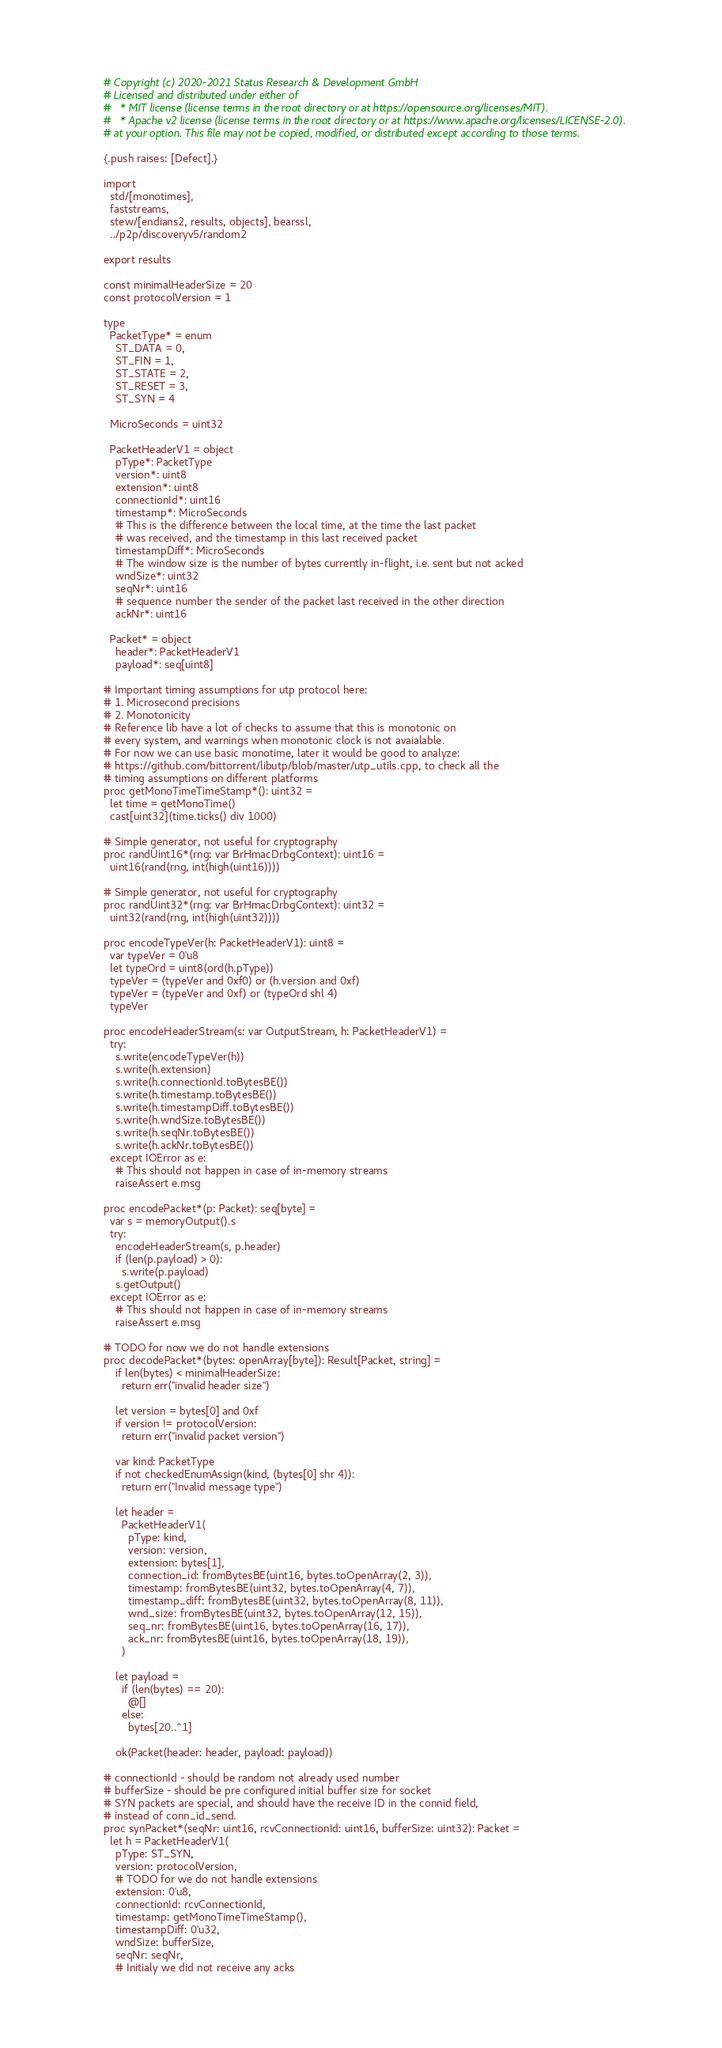Convert code to text. <code><loc_0><loc_0><loc_500><loc_500><_Nim_># Copyright (c) 2020-2021 Status Research & Development GmbH
# Licensed and distributed under either of
#   * MIT license (license terms in the root directory or at https://opensource.org/licenses/MIT).
#   * Apache v2 license (license terms in the root directory or at https://www.apache.org/licenses/LICENSE-2.0).
# at your option. This file may not be copied, modified, or distributed except according to those terms.

{.push raises: [Defect].}

import
  std/[monotimes],
  faststreams,
  stew/[endians2, results, objects], bearssl,
  ../p2p/discoveryv5/random2

export results

const minimalHeaderSize = 20
const protocolVersion = 1

type 
  PacketType* = enum
    ST_DATA = 0,
    ST_FIN = 1,
    ST_STATE = 2,
    ST_RESET = 3,
    ST_SYN = 4

  MicroSeconds = uint32

  PacketHeaderV1 = object
    pType*: PacketType
    version*: uint8
    extension*: uint8
    connectionId*: uint16
    timestamp*: MicroSeconds
    # This is the difference between the local time, at the time the last packet
    # was received, and the timestamp in this last received packet
    timestampDiff*: MicroSeconds
    # The window size is the number of bytes currently in-flight, i.e. sent but not acked
    wndSize*: uint32
    seqNr*: uint16
    # sequence number the sender of the packet last received in the other direction
    ackNr*: uint16

  Packet* = object
    header*: PacketHeaderV1
    payload*: seq[uint8]

# Important timing assumptions for utp protocol here:
# 1. Microsecond precisions
# 2. Monotonicity
# Reference lib have a lot of checks to assume that this is monotonic on
# every system, and warnings when monotonic clock is not avaialable.
# For now we can use basic monotime, later it would be good to analyze:
# https://github.com/bittorrent/libutp/blob/master/utp_utils.cpp, to check all the
# timing assumptions on different platforms
proc getMonoTimeTimeStamp*(): uint32 = 
  let time = getMonoTime()
  cast[uint32](time.ticks() div 1000)

# Simple generator, not useful for cryptography
proc randUint16*(rng: var BrHmacDrbgContext): uint16 =
  uint16(rand(rng, int(high(uint16))))

# Simple generator, not useful for cryptography
proc randUint32*(rng: var BrHmacDrbgContext): uint32 =
  uint32(rand(rng, int(high(uint32))))

proc encodeTypeVer(h: PacketHeaderV1): uint8 =
  var typeVer = 0'u8
  let typeOrd = uint8(ord(h.pType))
  typeVer = (typeVer and 0xf0) or (h.version and 0xf)
  typeVer = (typeVer and 0xf) or (typeOrd shl 4)
  typeVer

proc encodeHeaderStream(s: var OutputStream, h: PacketHeaderV1) =
  try:
    s.write(encodeTypeVer(h))
    s.write(h.extension)
    s.write(h.connectionId.toBytesBE())
    s.write(h.timestamp.toBytesBE())
    s.write(h.timestampDiff.toBytesBE())
    s.write(h.wndSize.toBytesBE())
    s.write(h.seqNr.toBytesBE())
    s.write(h.ackNr.toBytesBE())
  except IOError as e:
    # This should not happen in case of in-memory streams
    raiseAssert e.msg

proc encodePacket*(p: Packet): seq[byte] =
  var s = memoryOutput().s
  try:
    encodeHeaderStream(s, p.header)
    if (len(p.payload) > 0):
      s.write(p.payload)
    s.getOutput()
  except IOError as e:
    # This should not happen in case of in-memory streams
    raiseAssert e.msg
  
# TODO for now we do not handle extensions
proc decodePacket*(bytes: openArray[byte]): Result[Packet, string] =
    if len(bytes) < minimalHeaderSize:
      return err("invalid header size")

    let version = bytes[0] and 0xf
    if version != protocolVersion:
      return err("invalid packet version")
  
    var kind: PacketType
    if not checkedEnumAssign(kind, (bytes[0] shr 4)):
      return err("Invalid message type")
      
    let header =
      PacketHeaderV1(
        pType: kind,
        version: version,
        extension: bytes[1],
        connection_id: fromBytesBE(uint16, bytes.toOpenArray(2, 3)),
        timestamp: fromBytesBE(uint32, bytes.toOpenArray(4, 7)),
        timestamp_diff: fromBytesBE(uint32, bytes.toOpenArray(8, 11)),
        wnd_size: fromBytesBE(uint32, bytes.toOpenArray(12, 15)),
        seq_nr: fromBytesBE(uint16, bytes.toOpenArray(16, 17)),
        ack_nr: fromBytesBE(uint16, bytes.toOpenArray(18, 19)),
      )
    
    let payload =
      if (len(bytes) == 20):
        @[]
      else:
        bytes[20..^1]

    ok(Packet(header: header, payload: payload))

# connectionId - should be random not already used number
# bufferSize - should be pre configured initial buffer size for socket
# SYN packets are special, and should have the receive ID in the connid field,
# instead of conn_id_send.
proc synPacket*(seqNr: uint16, rcvConnectionId: uint16, bufferSize: uint32): Packet =
  let h = PacketHeaderV1(
    pType: ST_SYN,
    version: protocolVersion,
    # TODO for we do not handle extensions
    extension: 0'u8,
    connectionId: rcvConnectionId,
    timestamp: getMonoTimeTimeStamp(),
    timestampDiff: 0'u32,
    wndSize: bufferSize,
    seqNr: seqNr,
    # Initialy we did not receive any acks</code> 